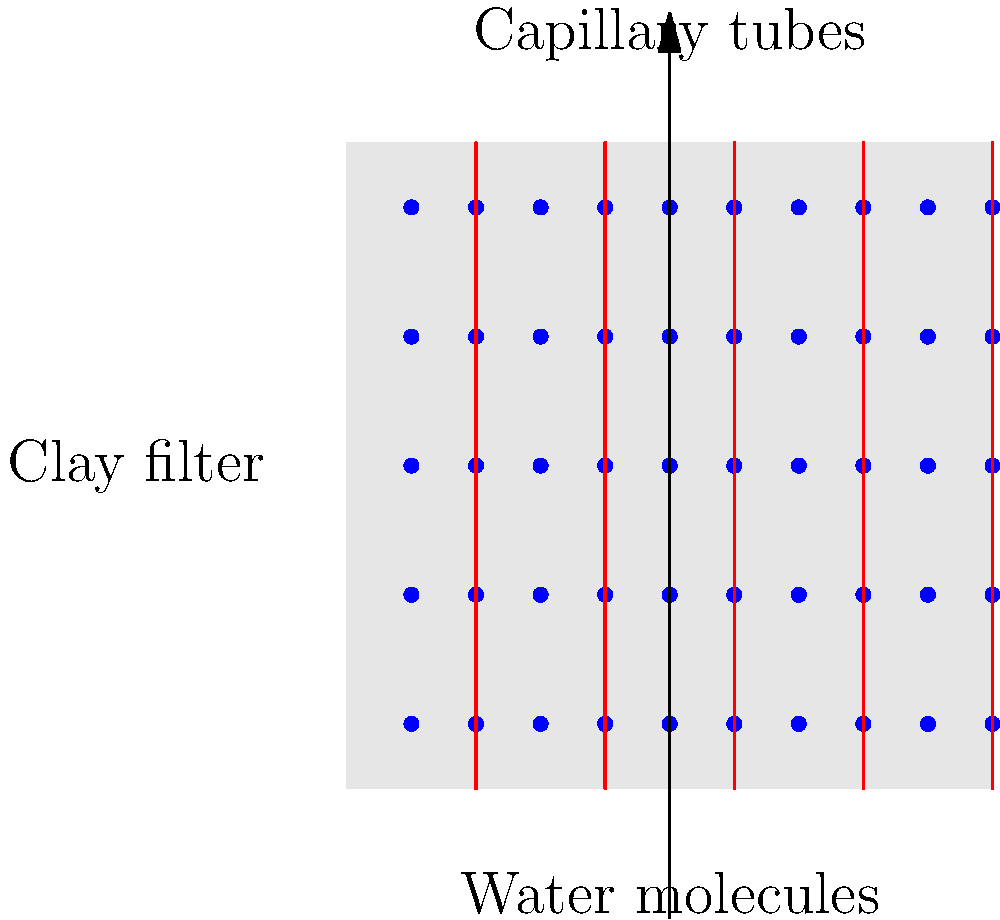In ancient clay water filters, capillary action plays a crucial role in purification. Given a microscopic view of such a filter, where the average pore radius is $r = 1 \times 10^{-6}$ m, the surface tension of water is $\gamma = 0.072$ N/m, and the contact angle between water and clay is $\theta = 20°$, calculate the maximum height $h$ that water can rise in the filter's capillary tubes. Assume the density of water $\rho = 1000$ kg/m³ and gravitational acceleration $g = 9.8$ m/s². To solve this problem, we'll use the capillary rise equation:

1) The capillary rise equation is:
   $$h = \frac{2\gamma \cos\theta}{\rho g r}$$

2) We have all the necessary values:
   - $r = 1 \times 10^{-6}$ m
   - $\gamma = 0.072$ N/m
   - $\theta = 20°$
   - $\rho = 1000$ kg/m³
   - $g = 9.8$ m/s²

3) First, calculate $\cos\theta$:
   $\cos 20° \approx 0.9397$

4) Now, substitute all values into the equation:
   $$h = \frac{2 \times 0.072 \times 0.9397}{1000 \times 9.8 \times 1 \times 10^{-6}}$$

5) Simplify:
   $$h = \frac{0.1353}{0.0098} = 13.80$$

6) The result is in meters, so:
   $h \approx 13.80$ m or 13.8 meters

This height demonstrates the significant capillary action in ancient clay filters, allowing water to rise against gravity and facilitating the filtration process.
Answer: 13.8 meters 